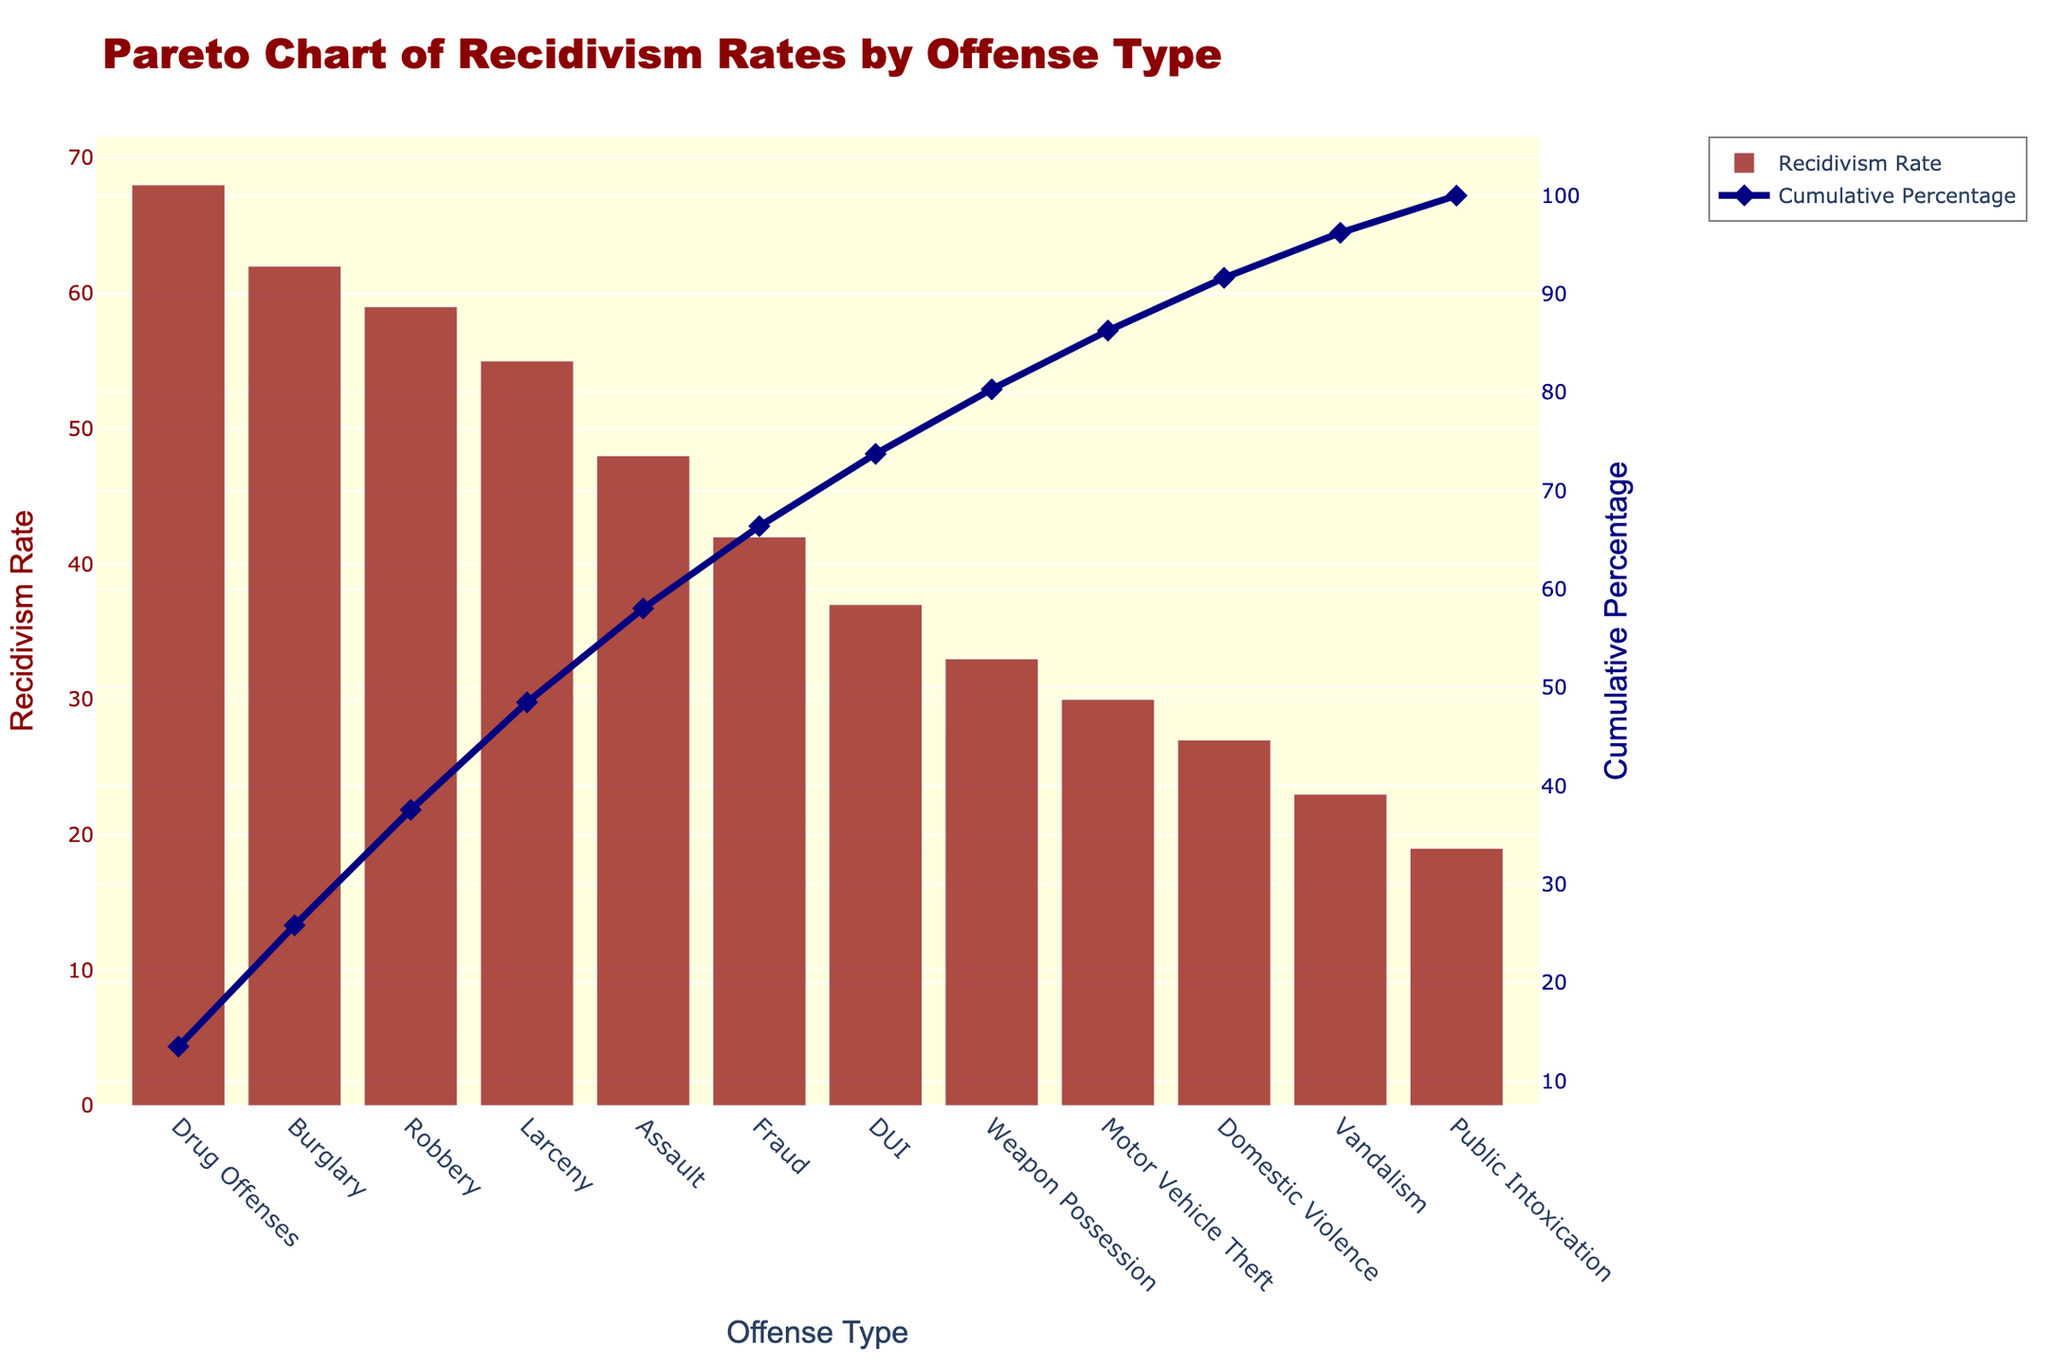What's the total number of offense types represented in the chart? Count the number of offense types listed on the x-axis. There are 12 different types: Drug Offenses, Burglary, Robbery, Larceny, Assault, Fraud, DUI, Weapon Possession, Motor Vehicle Theft, Domestic Violence, Vandalism, Public Intoxication.
Answer: 12 What is the offense type with the highest recidivism rate? Look at the bar with the highest value on the y-axis, which represents the recidivism rate. The highest bar is for Drug Offenses at 68%.
Answer: Drug Offenses What's the cumulative percentage after the top three offense types? Sum the recidivism rates of the top three offense types: Drug Offenses (68%), Burglary (62%), and Robbery (59%). The cumulative percentage is represented on the secondary y-axis. Adding these rates (68 + 62 + 59) gives 189%, and the cumulative percentage is the corresponding value on the line chart.
Answer: 61.81% Which offense type has a recidivism rate just below 40%? Look for the bar that corresponds to a value just under 40% on the primary y-axis. The offense type here is Weapon Possession with a recidivism rate of 33%.
Answer: Weapon Possession How does the recidivism rate for Domestic Violence compare to that for Fraud? Compare the two bars associated with Domestic Violence and Fraud. Domestic Violence has a recidivism rate of 27%, and Fraud has 42%.
Answer: Lower Which offense types have a recidivism rate above 50%? Identify all bars that exceed the 50% mark on the primary y-axis. Drug Offenses (68%), Burglary (62%), Robbery (59%), and Larceny (55%) all meet this criterion.
Answer: Drug Offenses, Burglary, Robbery, Larceny What percentage of the total recidivism rate is accounted for by the top five offense types? Add the recidivism rates for the top five offense types: 68% (Drug Offenses) + 62% (Burglary) + 59% (Robbery) + 55% (Larceny) + 48% (Assault) = 292%. Divide this by the sum of all recidivism rates and multiply by 100 to get the percentage. The total sum is 495%, so (292 / 495) * 100 = 59.00%.
Answer: 59.00% Which offense type reached a cumulative percentage of about 50% by itself? Look for the offense type that causes the cumulative line on the secondary y-axis to reach around 50%. Drug Offenses alone reaches 50%, but Burglary exceeds it.
Answer: Drug Offenses 